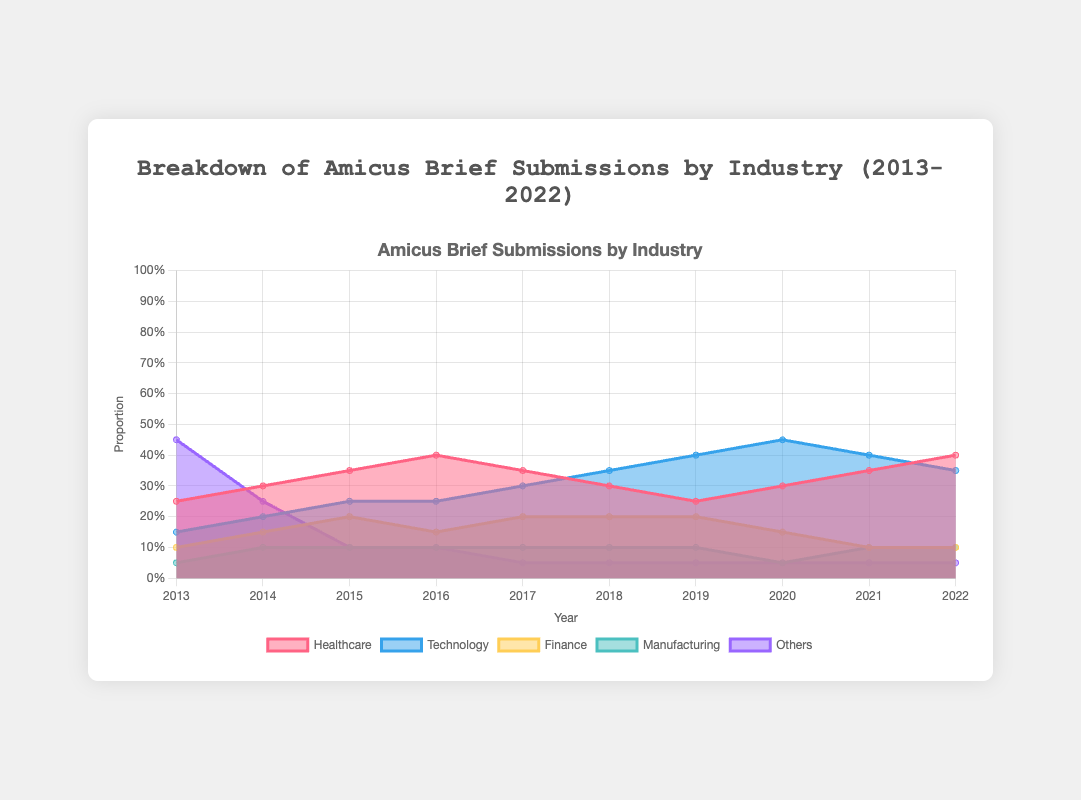What is the title of the chart? The title of the chart is centered at the top and reads "Breakdown of Amicus Brief Submissions by Industry (2013-2022)".
Answer: Breakdown of Amicus Brief Submissions by Industry (2013-2022) What were the proportions of amicus brief submissions by the Healthcare industry in 2013 and 2022? Look at the areas corresponding to the Healthcare industry for the years 2013 and 2022. Read the values directly from the y-axis.
Answer: 0.25 in 2013 and 0.40 in 2022 Which industry saw the largest increase in the proportion of amicus brief submissions from 2013 to 2022? Compare the proportions of each industry from 2013 to 2022 and find the difference for each. The largest positive difference indicates the industry with the largest increase.
Answer: Technology In which year did the Finance industry have the highest proportion of amicus brief submissions? Look at the area chart for the Finance industry across all years and identify the year with the highest point on the y-axis.
Answer: 2015 What was the combined proportion of submissions by the Healthcare and Technology industries in 2019? Locate the proportions for Healthcare and Technology in 2019, then sum these proportions: 0.25 (Healthcare) + 0.40 (Technology).
Answer: 0.65 Did any industry have a decreasing trend for the proportion of submissions from 2013 to 2022? Observe the trend lines for each industry from 2013 to 2022 to identify any industry with a consistently decreasing trend.
Answer: No Which industry always had the smallest contribution from 2013 to 2022? Examine the area chart to see which industry's area is always the lowest across all the years.
Answer: Manufacturing In how many years did the proportion of submissions by the Technology industry exceed 0.30? Count the number of years where the area representing Technology exceeds the 0.30 mark on the y-axis.
Answer: 6 years What was the proportion of "Others" in 2017 compared to 2013? Check the proportions for "Others" in 2017 and 2013 and compare them directly.
Answer: 0.05 in 2017 and 0.45 in 2013 Did the proportion of amicus brief submissions by the Healthcare industry ever fall below 0.25? If so, in which year(s)? View the area chart for the Healthcare industry and identify any years where the proportion falls below the 0.25 mark on the y-axis.
Answer: No 